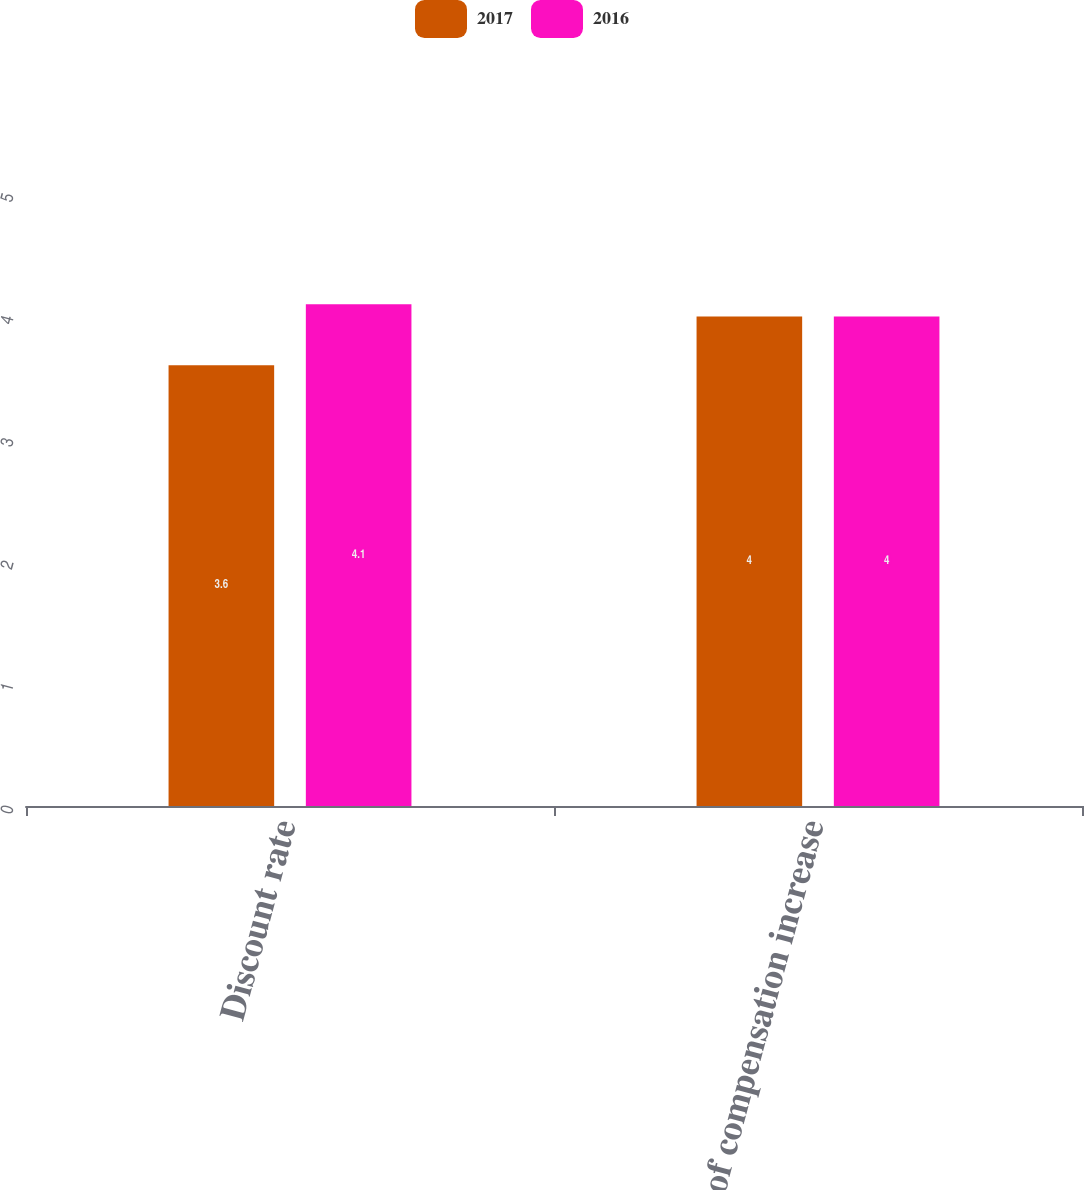Convert chart to OTSL. <chart><loc_0><loc_0><loc_500><loc_500><stacked_bar_chart><ecel><fcel>Discount rate<fcel>Rate of compensation increase<nl><fcel>2017<fcel>3.6<fcel>4<nl><fcel>2016<fcel>4.1<fcel>4<nl></chart> 